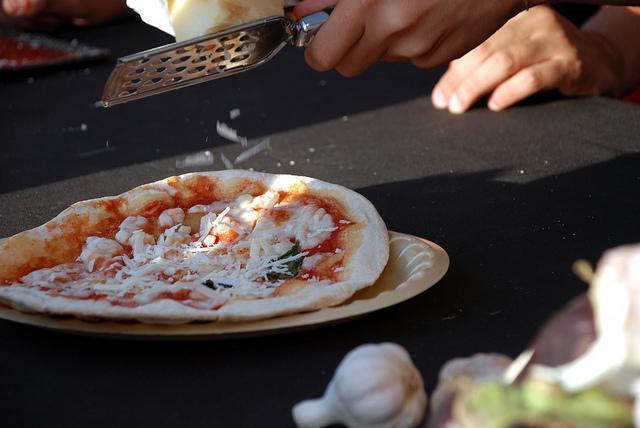How many people are there?
Give a very brief answer. 2. 